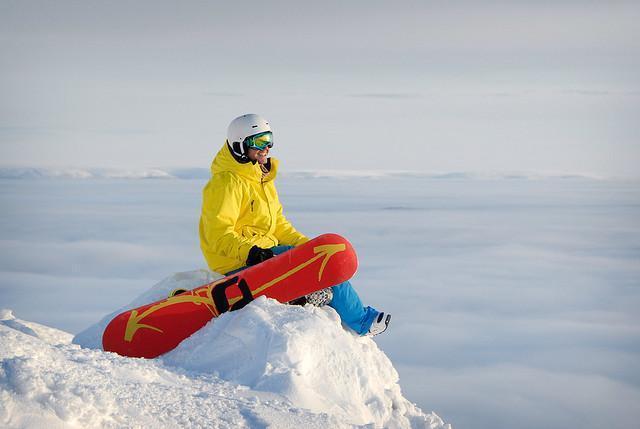How many bananas doe the guy have in his back pocket?
Give a very brief answer. 0. 